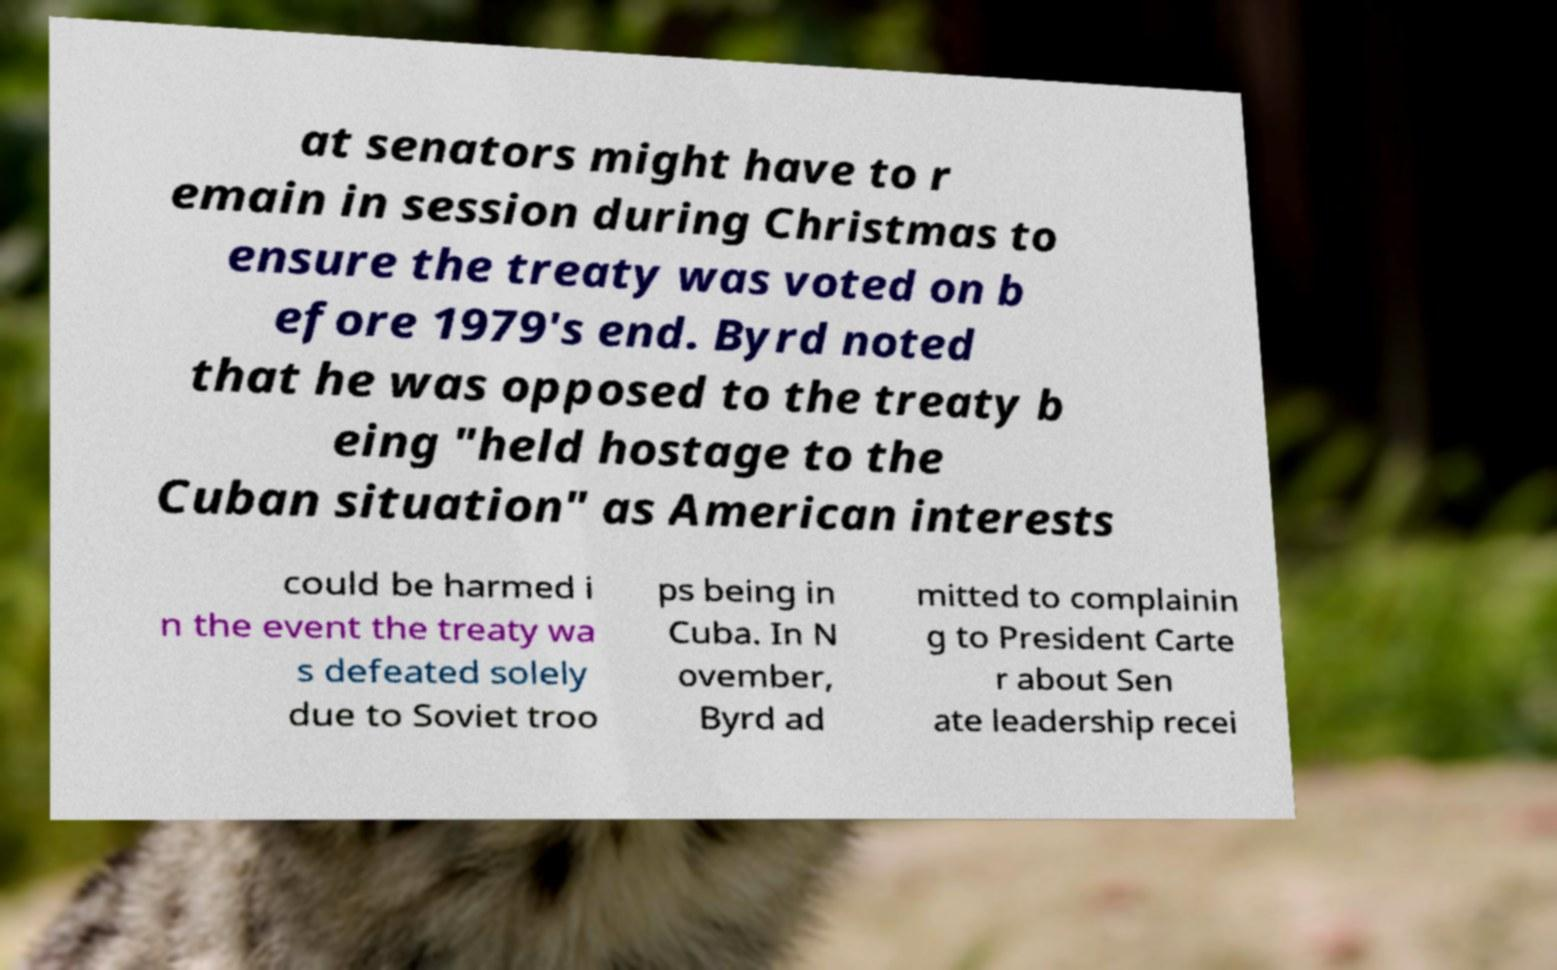I need the written content from this picture converted into text. Can you do that? at senators might have to r emain in session during Christmas to ensure the treaty was voted on b efore 1979's end. Byrd noted that he was opposed to the treaty b eing "held hostage to the Cuban situation" as American interests could be harmed i n the event the treaty wa s defeated solely due to Soviet troo ps being in Cuba. In N ovember, Byrd ad mitted to complainin g to President Carte r about Sen ate leadership recei 